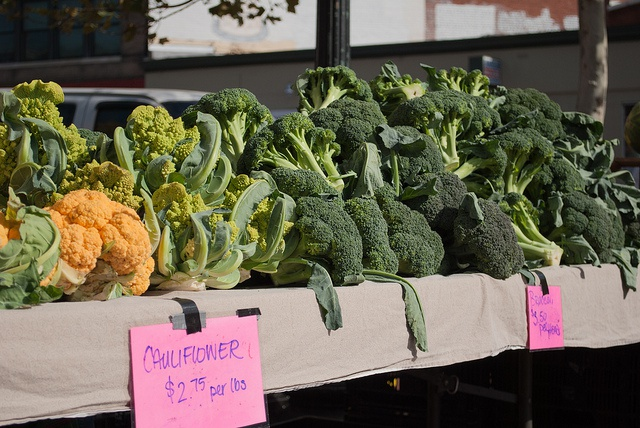Describe the objects in this image and their specific colors. I can see broccoli in black, olive, and orange tones, broccoli in black, darkgreen, and olive tones, broccoli in black and darkgreen tones, broccoli in black and darkgreen tones, and broccoli in black, gray, and darkgreen tones in this image. 